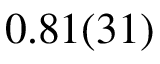<formula> <loc_0><loc_0><loc_500><loc_500>0 . 8 1 ( 3 1 )</formula> 